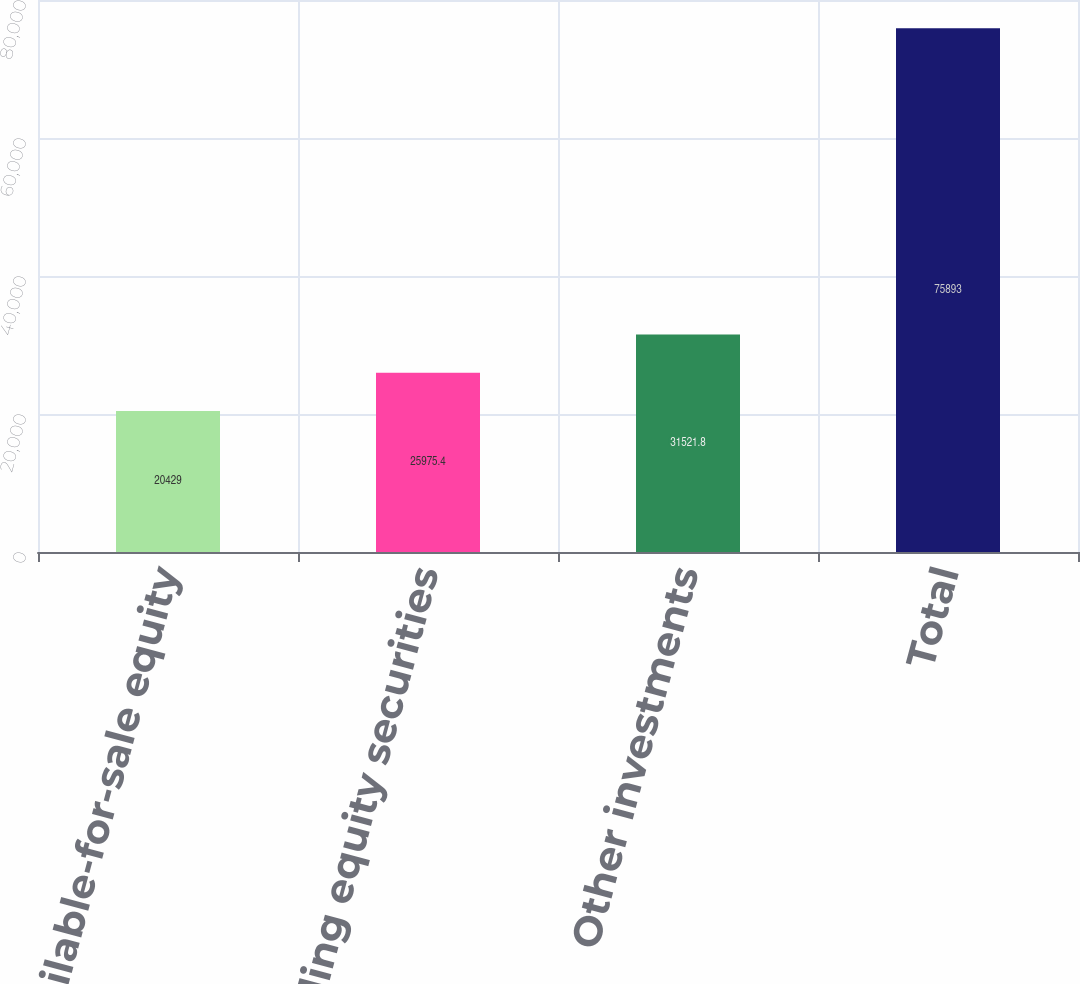Convert chart to OTSL. <chart><loc_0><loc_0><loc_500><loc_500><bar_chart><fcel>Available-for-sale equity<fcel>Trading equity securities<fcel>Other investments<fcel>Total<nl><fcel>20429<fcel>25975.4<fcel>31521.8<fcel>75893<nl></chart> 